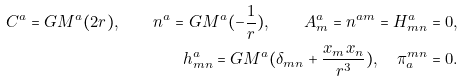<formula> <loc_0><loc_0><loc_500><loc_500>C ^ { a } = G M ^ { a } ( 2 r ) , \quad n ^ { a } = G M ^ { a } ( - \frac { 1 } { r } ) , \quad A ^ { a } _ { m } = n ^ { a m } = H ^ { a } _ { m n } = 0 , \\ h ^ { a } _ { m n } = G M ^ { a } ( \delta _ { m n } + \frac { x _ { m } x _ { n } } { r ^ { 3 } } ) , \quad \pi _ { a } ^ { m n } = 0 .</formula> 